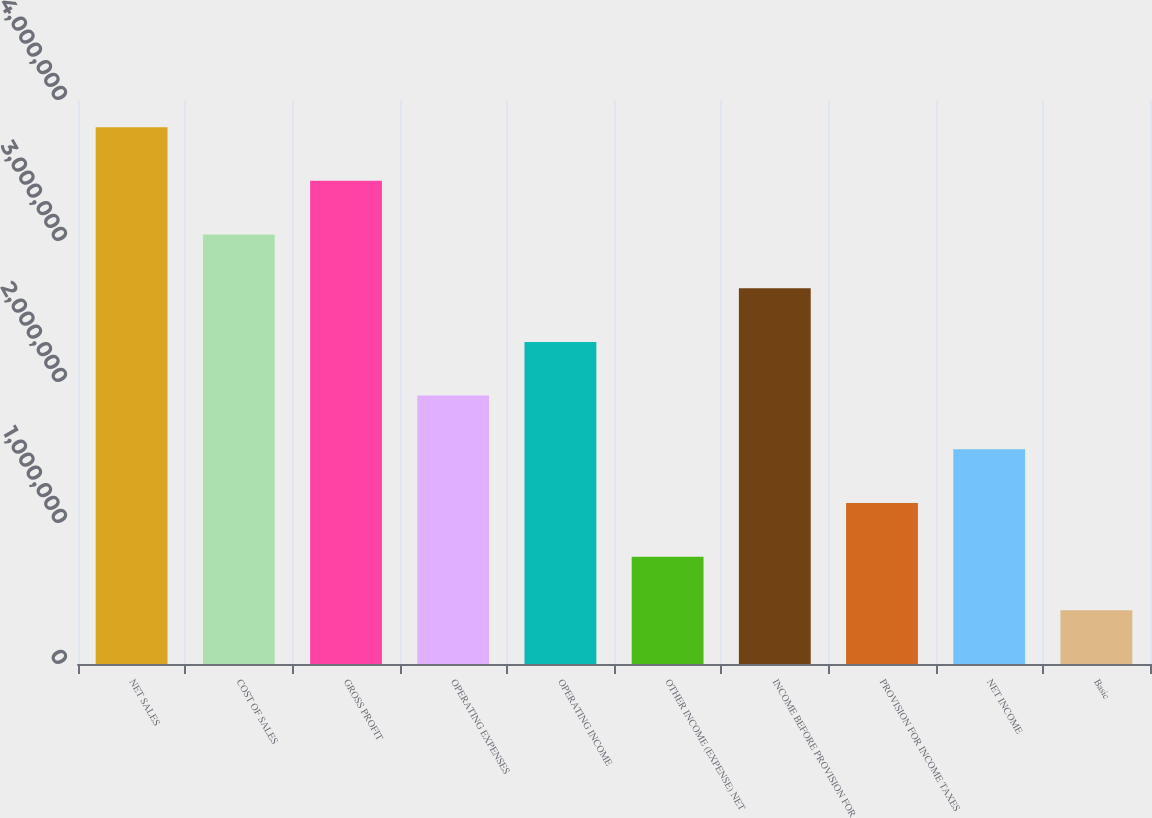<chart> <loc_0><loc_0><loc_500><loc_500><bar_chart><fcel>NET SALES<fcel>COST OF SALES<fcel>GROSS PROFIT<fcel>OPERATING EXPENSES<fcel>OPERATING INCOME<fcel>OTHER INCOME (EXPENSE) NET<fcel>INCOME BEFORE PROVISION FOR<fcel>PROVISION FOR INCOME TAXES<fcel>NET INCOME<fcel>Basic<nl><fcel>3.80718e+06<fcel>3.04575e+06<fcel>3.42646e+06<fcel>1.90359e+06<fcel>2.28431e+06<fcel>761438<fcel>2.66503e+06<fcel>1.14216e+06<fcel>1.52287e+06<fcel>380720<nl></chart> 